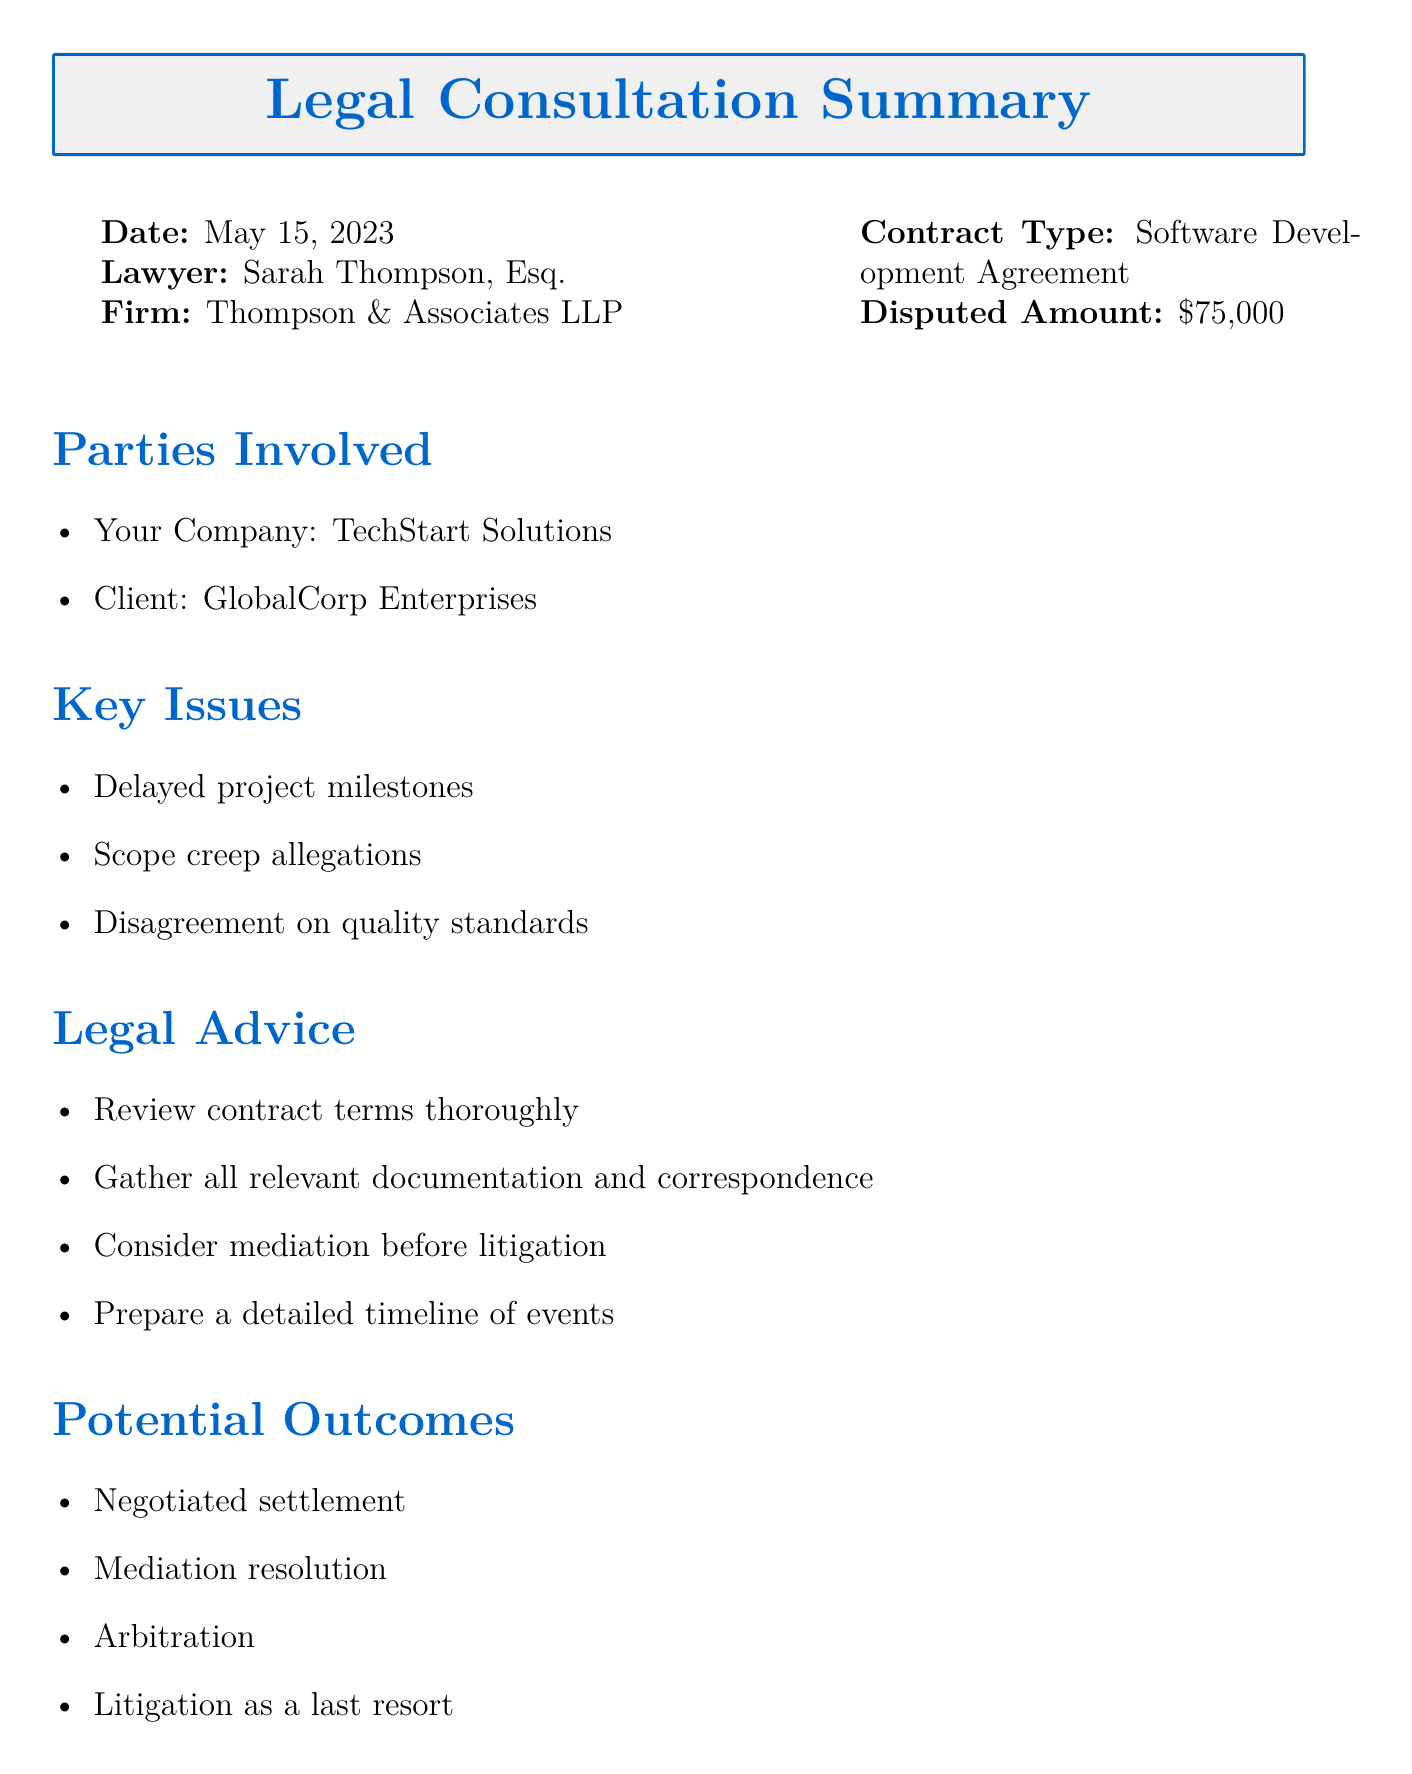What is the date of the consultation? The date of the consultation is mentioned at the beginning of the document as May 15, 2023.
Answer: May 15, 2023 Who is the lawyer representing you? The lawyer's name is provided in the consultation details section of the document, which is Sarah Thompson, Esq.
Answer: Sarah Thompson, Esq What is the disputed amount in the contract? The disputed amount is explicitly stated in the contract dispute overview section as $75,000.
Answer: $75,000 What are the key issues in the dispute? The key issues listed in the document include delayed project milestones, scope creep allegations, and disagreement on quality standards.
Answer: Delayed project milestones, scope creep allegations, disagreement on quality standards What is the estimated resolution time? The estimated resolution time is given in the timeline section of the document as 3-6 months.
Answer: 3-6 months What are the potential outcomes listed in the document? The potential outcomes mentioned in the document include negotiated settlement, mediation resolution, arbitration, and litigation as a last resort.
Answer: Negotiated settlement, mediation resolution, arbitration, litigation as a last resort What is the legal fees estimate? The estimated legal fees are mentioned specifically in the costs section of the document as $5,000 - $15,000 initially.
Answer: $5,000 - $15,000 When is the response deadline? The response deadline is provided in the timeline section of the document, indicating the date by which a response is due as June 1, 2023.
Answer: June 1, 2023 